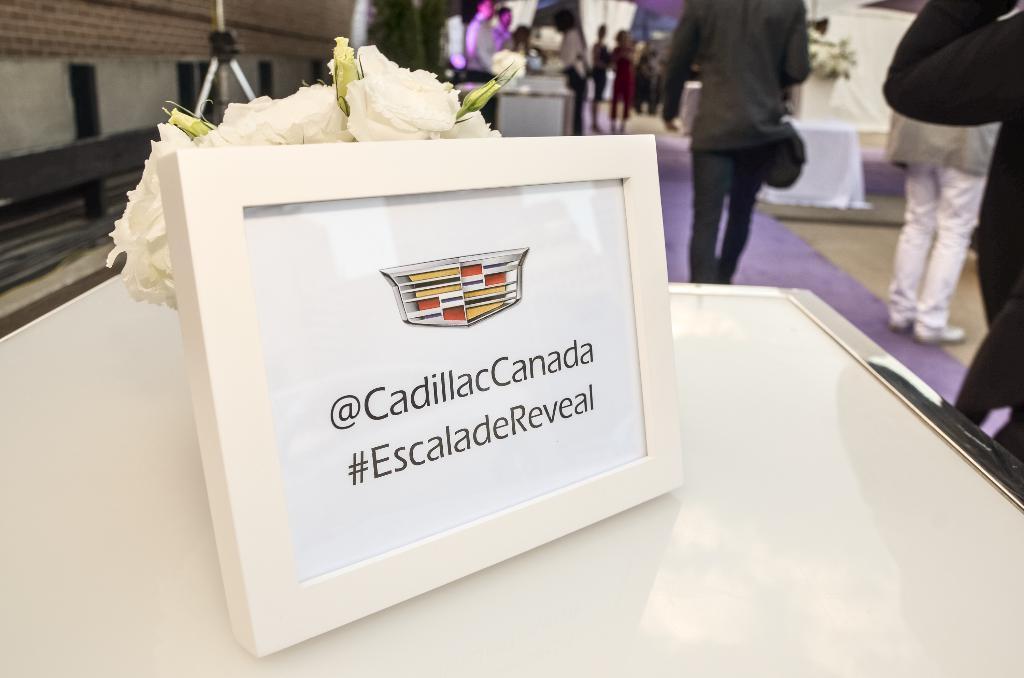Could you give a brief overview of what you see in this image? In this image in the front there is a boat with some text written on it. In the center there are objects which are white in colour and there are persons standing and walking. In the background there are plants and there are persons and there are curtains which are white in colour and there are tables, on the table there is a flower vase. 